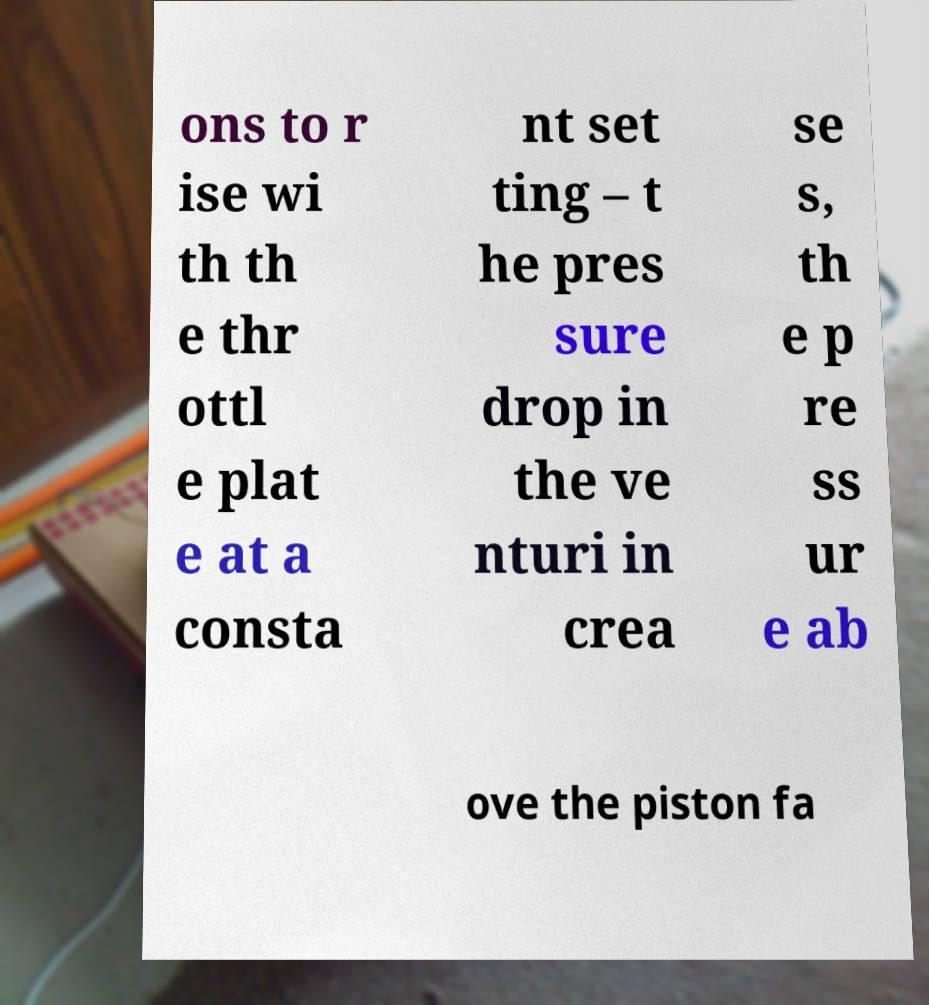Please read and relay the text visible in this image. What does it say? ons to r ise wi th th e thr ottl e plat e at a consta nt set ting – t he pres sure drop in the ve nturi in crea se s, th e p re ss ur e ab ove the piston fa 